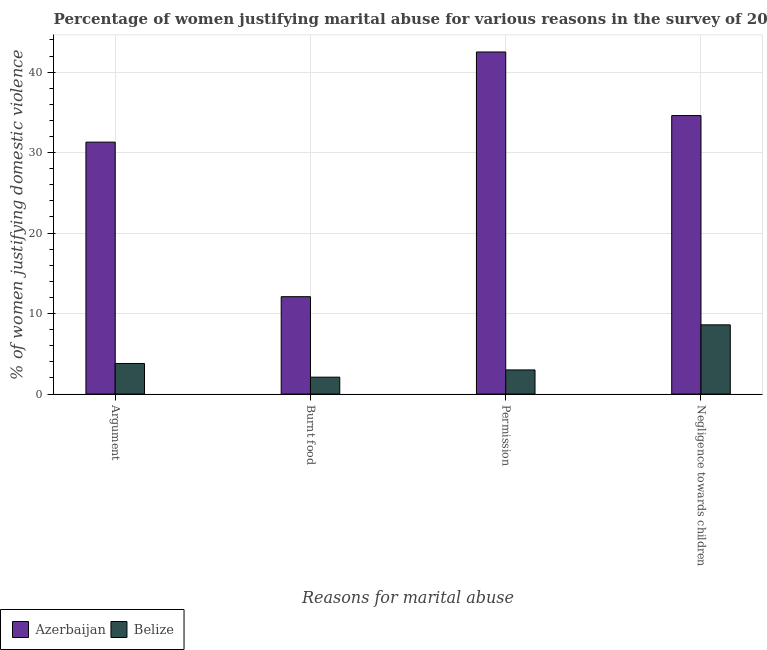How many bars are there on the 3rd tick from the left?
Offer a very short reply. 2. What is the label of the 3rd group of bars from the left?
Offer a terse response. Permission. Across all countries, what is the minimum percentage of women justifying abuse for going without permission?
Keep it short and to the point. 3. In which country was the percentage of women justifying abuse for going without permission maximum?
Ensure brevity in your answer.  Azerbaijan. In which country was the percentage of women justifying abuse in the case of an argument minimum?
Offer a very short reply. Belize. What is the total percentage of women justifying abuse for going without permission in the graph?
Your response must be concise. 45.5. What is the difference between the percentage of women justifying abuse for burning food in Azerbaijan and the percentage of women justifying abuse in the case of an argument in Belize?
Provide a short and direct response. 8.3. What is the average percentage of women justifying abuse in the case of an argument per country?
Provide a short and direct response. 17.55. What is the difference between the percentage of women justifying abuse for going without permission and percentage of women justifying abuse in the case of an argument in Azerbaijan?
Keep it short and to the point. 11.2. What is the ratio of the percentage of women justifying abuse for going without permission in Azerbaijan to that in Belize?
Offer a terse response. 14.17. Is the percentage of women justifying abuse for showing negligence towards children in Azerbaijan less than that in Belize?
Ensure brevity in your answer.  No. What is the difference between the highest and the second highest percentage of women justifying abuse for showing negligence towards children?
Offer a terse response. 26. In how many countries, is the percentage of women justifying abuse for showing negligence towards children greater than the average percentage of women justifying abuse for showing negligence towards children taken over all countries?
Keep it short and to the point. 1. Is the sum of the percentage of women justifying abuse in the case of an argument in Azerbaijan and Belize greater than the maximum percentage of women justifying abuse for burning food across all countries?
Your answer should be very brief. Yes. Is it the case that in every country, the sum of the percentage of women justifying abuse for showing negligence towards children and percentage of women justifying abuse for burning food is greater than the sum of percentage of women justifying abuse for going without permission and percentage of women justifying abuse in the case of an argument?
Your response must be concise. No. What does the 2nd bar from the left in Permission represents?
Provide a succinct answer. Belize. What does the 1st bar from the right in Negligence towards children represents?
Provide a succinct answer. Belize. Is it the case that in every country, the sum of the percentage of women justifying abuse in the case of an argument and percentage of women justifying abuse for burning food is greater than the percentage of women justifying abuse for going without permission?
Provide a succinct answer. Yes. What is the difference between two consecutive major ticks on the Y-axis?
Offer a terse response. 10. How many legend labels are there?
Offer a very short reply. 2. How are the legend labels stacked?
Make the answer very short. Horizontal. What is the title of the graph?
Your answer should be very brief. Percentage of women justifying marital abuse for various reasons in the survey of 2006. Does "Belize" appear as one of the legend labels in the graph?
Keep it short and to the point. Yes. What is the label or title of the X-axis?
Ensure brevity in your answer.  Reasons for marital abuse. What is the label or title of the Y-axis?
Keep it short and to the point. % of women justifying domestic violence. What is the % of women justifying domestic violence of Azerbaijan in Argument?
Provide a short and direct response. 31.3. What is the % of women justifying domestic violence in Belize in Argument?
Give a very brief answer. 3.8. What is the % of women justifying domestic violence in Belize in Burnt food?
Make the answer very short. 2.1. What is the % of women justifying domestic violence in Azerbaijan in Permission?
Provide a succinct answer. 42.5. What is the % of women justifying domestic violence in Belize in Permission?
Give a very brief answer. 3. What is the % of women justifying domestic violence of Azerbaijan in Negligence towards children?
Your answer should be compact. 34.6. Across all Reasons for marital abuse, what is the maximum % of women justifying domestic violence in Azerbaijan?
Give a very brief answer. 42.5. Across all Reasons for marital abuse, what is the minimum % of women justifying domestic violence in Azerbaijan?
Provide a succinct answer. 12.1. Across all Reasons for marital abuse, what is the minimum % of women justifying domestic violence in Belize?
Provide a short and direct response. 2.1. What is the total % of women justifying domestic violence in Azerbaijan in the graph?
Ensure brevity in your answer.  120.5. What is the difference between the % of women justifying domestic violence of Azerbaijan in Argument and that in Permission?
Offer a terse response. -11.2. What is the difference between the % of women justifying domestic violence of Azerbaijan in Argument and that in Negligence towards children?
Give a very brief answer. -3.3. What is the difference between the % of women justifying domestic violence of Belize in Argument and that in Negligence towards children?
Your answer should be compact. -4.8. What is the difference between the % of women justifying domestic violence of Azerbaijan in Burnt food and that in Permission?
Your answer should be compact. -30.4. What is the difference between the % of women justifying domestic violence in Azerbaijan in Burnt food and that in Negligence towards children?
Your answer should be compact. -22.5. What is the difference between the % of women justifying domestic violence in Belize in Burnt food and that in Negligence towards children?
Your answer should be very brief. -6.5. What is the difference between the % of women justifying domestic violence in Azerbaijan in Permission and that in Negligence towards children?
Keep it short and to the point. 7.9. What is the difference between the % of women justifying domestic violence of Belize in Permission and that in Negligence towards children?
Your response must be concise. -5.6. What is the difference between the % of women justifying domestic violence of Azerbaijan in Argument and the % of women justifying domestic violence of Belize in Burnt food?
Ensure brevity in your answer.  29.2. What is the difference between the % of women justifying domestic violence of Azerbaijan in Argument and the % of women justifying domestic violence of Belize in Permission?
Give a very brief answer. 28.3. What is the difference between the % of women justifying domestic violence of Azerbaijan in Argument and the % of women justifying domestic violence of Belize in Negligence towards children?
Keep it short and to the point. 22.7. What is the difference between the % of women justifying domestic violence in Azerbaijan in Burnt food and the % of women justifying domestic violence in Belize in Permission?
Your response must be concise. 9.1. What is the difference between the % of women justifying domestic violence in Azerbaijan in Burnt food and the % of women justifying domestic violence in Belize in Negligence towards children?
Offer a terse response. 3.5. What is the difference between the % of women justifying domestic violence in Azerbaijan in Permission and the % of women justifying domestic violence in Belize in Negligence towards children?
Give a very brief answer. 33.9. What is the average % of women justifying domestic violence of Azerbaijan per Reasons for marital abuse?
Your response must be concise. 30.12. What is the average % of women justifying domestic violence of Belize per Reasons for marital abuse?
Offer a very short reply. 4.38. What is the difference between the % of women justifying domestic violence in Azerbaijan and % of women justifying domestic violence in Belize in Argument?
Provide a succinct answer. 27.5. What is the difference between the % of women justifying domestic violence in Azerbaijan and % of women justifying domestic violence in Belize in Burnt food?
Your response must be concise. 10. What is the difference between the % of women justifying domestic violence in Azerbaijan and % of women justifying domestic violence in Belize in Permission?
Keep it short and to the point. 39.5. What is the difference between the % of women justifying domestic violence in Azerbaijan and % of women justifying domestic violence in Belize in Negligence towards children?
Keep it short and to the point. 26. What is the ratio of the % of women justifying domestic violence in Azerbaijan in Argument to that in Burnt food?
Your answer should be compact. 2.59. What is the ratio of the % of women justifying domestic violence in Belize in Argument to that in Burnt food?
Provide a short and direct response. 1.81. What is the ratio of the % of women justifying domestic violence of Azerbaijan in Argument to that in Permission?
Offer a terse response. 0.74. What is the ratio of the % of women justifying domestic violence of Belize in Argument to that in Permission?
Provide a succinct answer. 1.27. What is the ratio of the % of women justifying domestic violence of Azerbaijan in Argument to that in Negligence towards children?
Offer a terse response. 0.9. What is the ratio of the % of women justifying domestic violence in Belize in Argument to that in Negligence towards children?
Give a very brief answer. 0.44. What is the ratio of the % of women justifying domestic violence of Azerbaijan in Burnt food to that in Permission?
Your answer should be compact. 0.28. What is the ratio of the % of women justifying domestic violence in Azerbaijan in Burnt food to that in Negligence towards children?
Your answer should be compact. 0.35. What is the ratio of the % of women justifying domestic violence in Belize in Burnt food to that in Negligence towards children?
Your answer should be compact. 0.24. What is the ratio of the % of women justifying domestic violence of Azerbaijan in Permission to that in Negligence towards children?
Give a very brief answer. 1.23. What is the ratio of the % of women justifying domestic violence in Belize in Permission to that in Negligence towards children?
Your response must be concise. 0.35. What is the difference between the highest and the second highest % of women justifying domestic violence in Azerbaijan?
Your answer should be very brief. 7.9. What is the difference between the highest and the second highest % of women justifying domestic violence in Belize?
Provide a succinct answer. 4.8. What is the difference between the highest and the lowest % of women justifying domestic violence of Azerbaijan?
Your response must be concise. 30.4. 